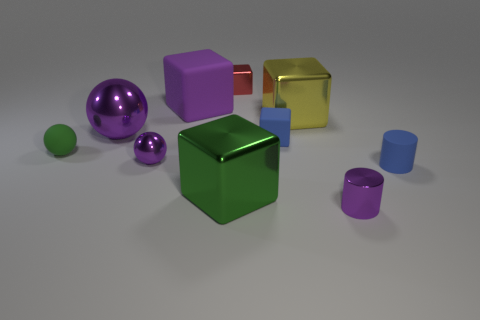Is the number of matte objects that are right of the red shiny thing the same as the number of tiny matte cylinders?
Provide a succinct answer. No. Is there anything else that has the same size as the purple cylinder?
Make the answer very short. Yes. How many objects are tiny brown rubber objects or large matte blocks?
Ensure brevity in your answer.  1. There is a green object that is made of the same material as the tiny red block; what is its shape?
Give a very brief answer. Cube. How big is the green thing behind the large metallic block that is in front of the large purple ball?
Keep it short and to the point. Small. How many large things are green cylinders or red things?
Offer a very short reply. 0. What number of other things are there of the same color as the rubber ball?
Provide a succinct answer. 1. Does the purple sphere behind the small green sphere have the same size as the metallic cube behind the large purple matte thing?
Give a very brief answer. No. Do the big green thing and the small purple object on the left side of the blue cube have the same material?
Keep it short and to the point. Yes. Are there more big purple shiny balls that are on the left side of the red object than blue things behind the yellow metal cube?
Provide a short and direct response. Yes. 